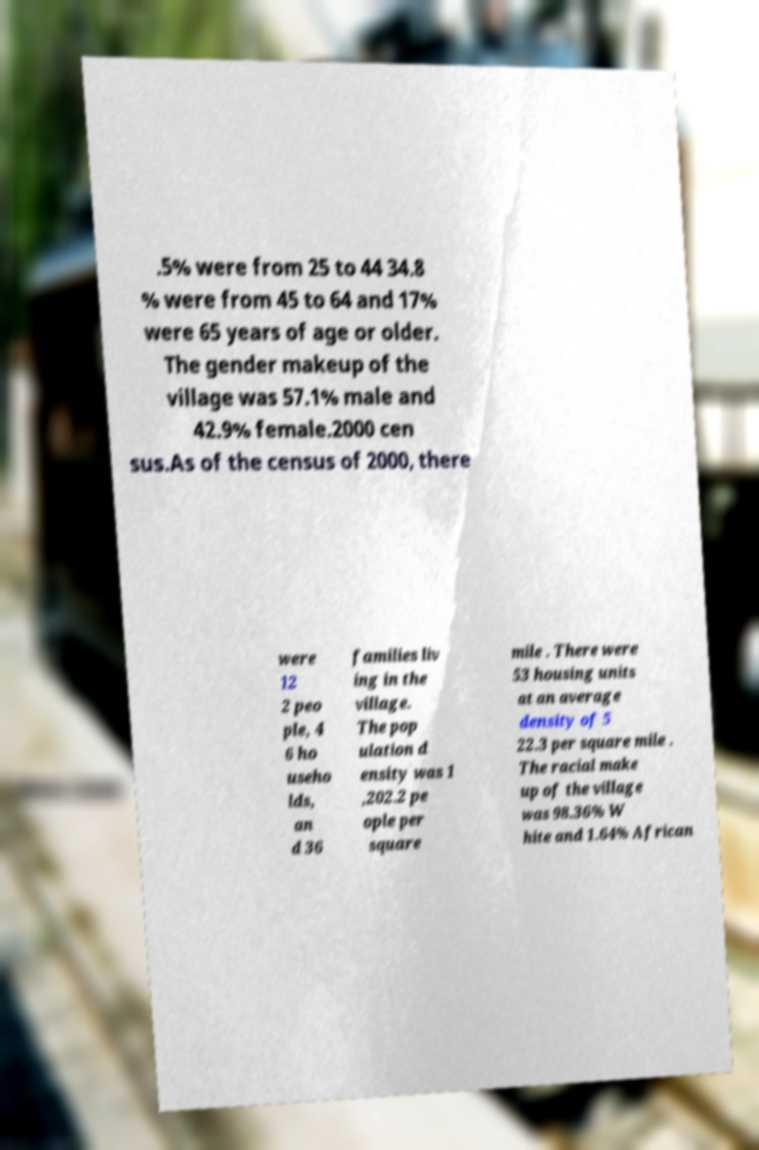Could you extract and type out the text from this image? .5% were from 25 to 44 34.8 % were from 45 to 64 and 17% were 65 years of age or older. The gender makeup of the village was 57.1% male and 42.9% female.2000 cen sus.As of the census of 2000, there were 12 2 peo ple, 4 6 ho useho lds, an d 36 families liv ing in the village. The pop ulation d ensity was 1 ,202.2 pe ople per square mile . There were 53 housing units at an average density of 5 22.3 per square mile . The racial make up of the village was 98.36% W hite and 1.64% African 